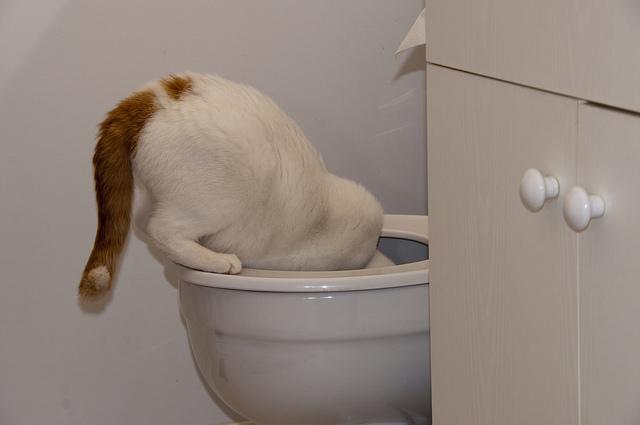Is there a cabinet next to the toilet?
Quick response, please. Yes. What color is the cat?
Concise answer only. White. What is the cat putting his face in?
Quick response, please. Toilet. What type of animal is this?
Answer briefly. Cat. Is there more than one cat?
Give a very brief answer. No. How many pets are present?
Write a very short answer. 1. What color is the cat's tail?
Be succinct. Orange. What is the cat doing?
Concise answer only. Drinking. What type of cat is this?
Be succinct. House cat. What kind of animal is holding the bowl?
Answer briefly. Cat. What pattern is on the bowl?
Be succinct. None. Does the kitten want the water?
Give a very brief answer. Yes. What is the cat drinking out of?
Concise answer only. Toilet. 